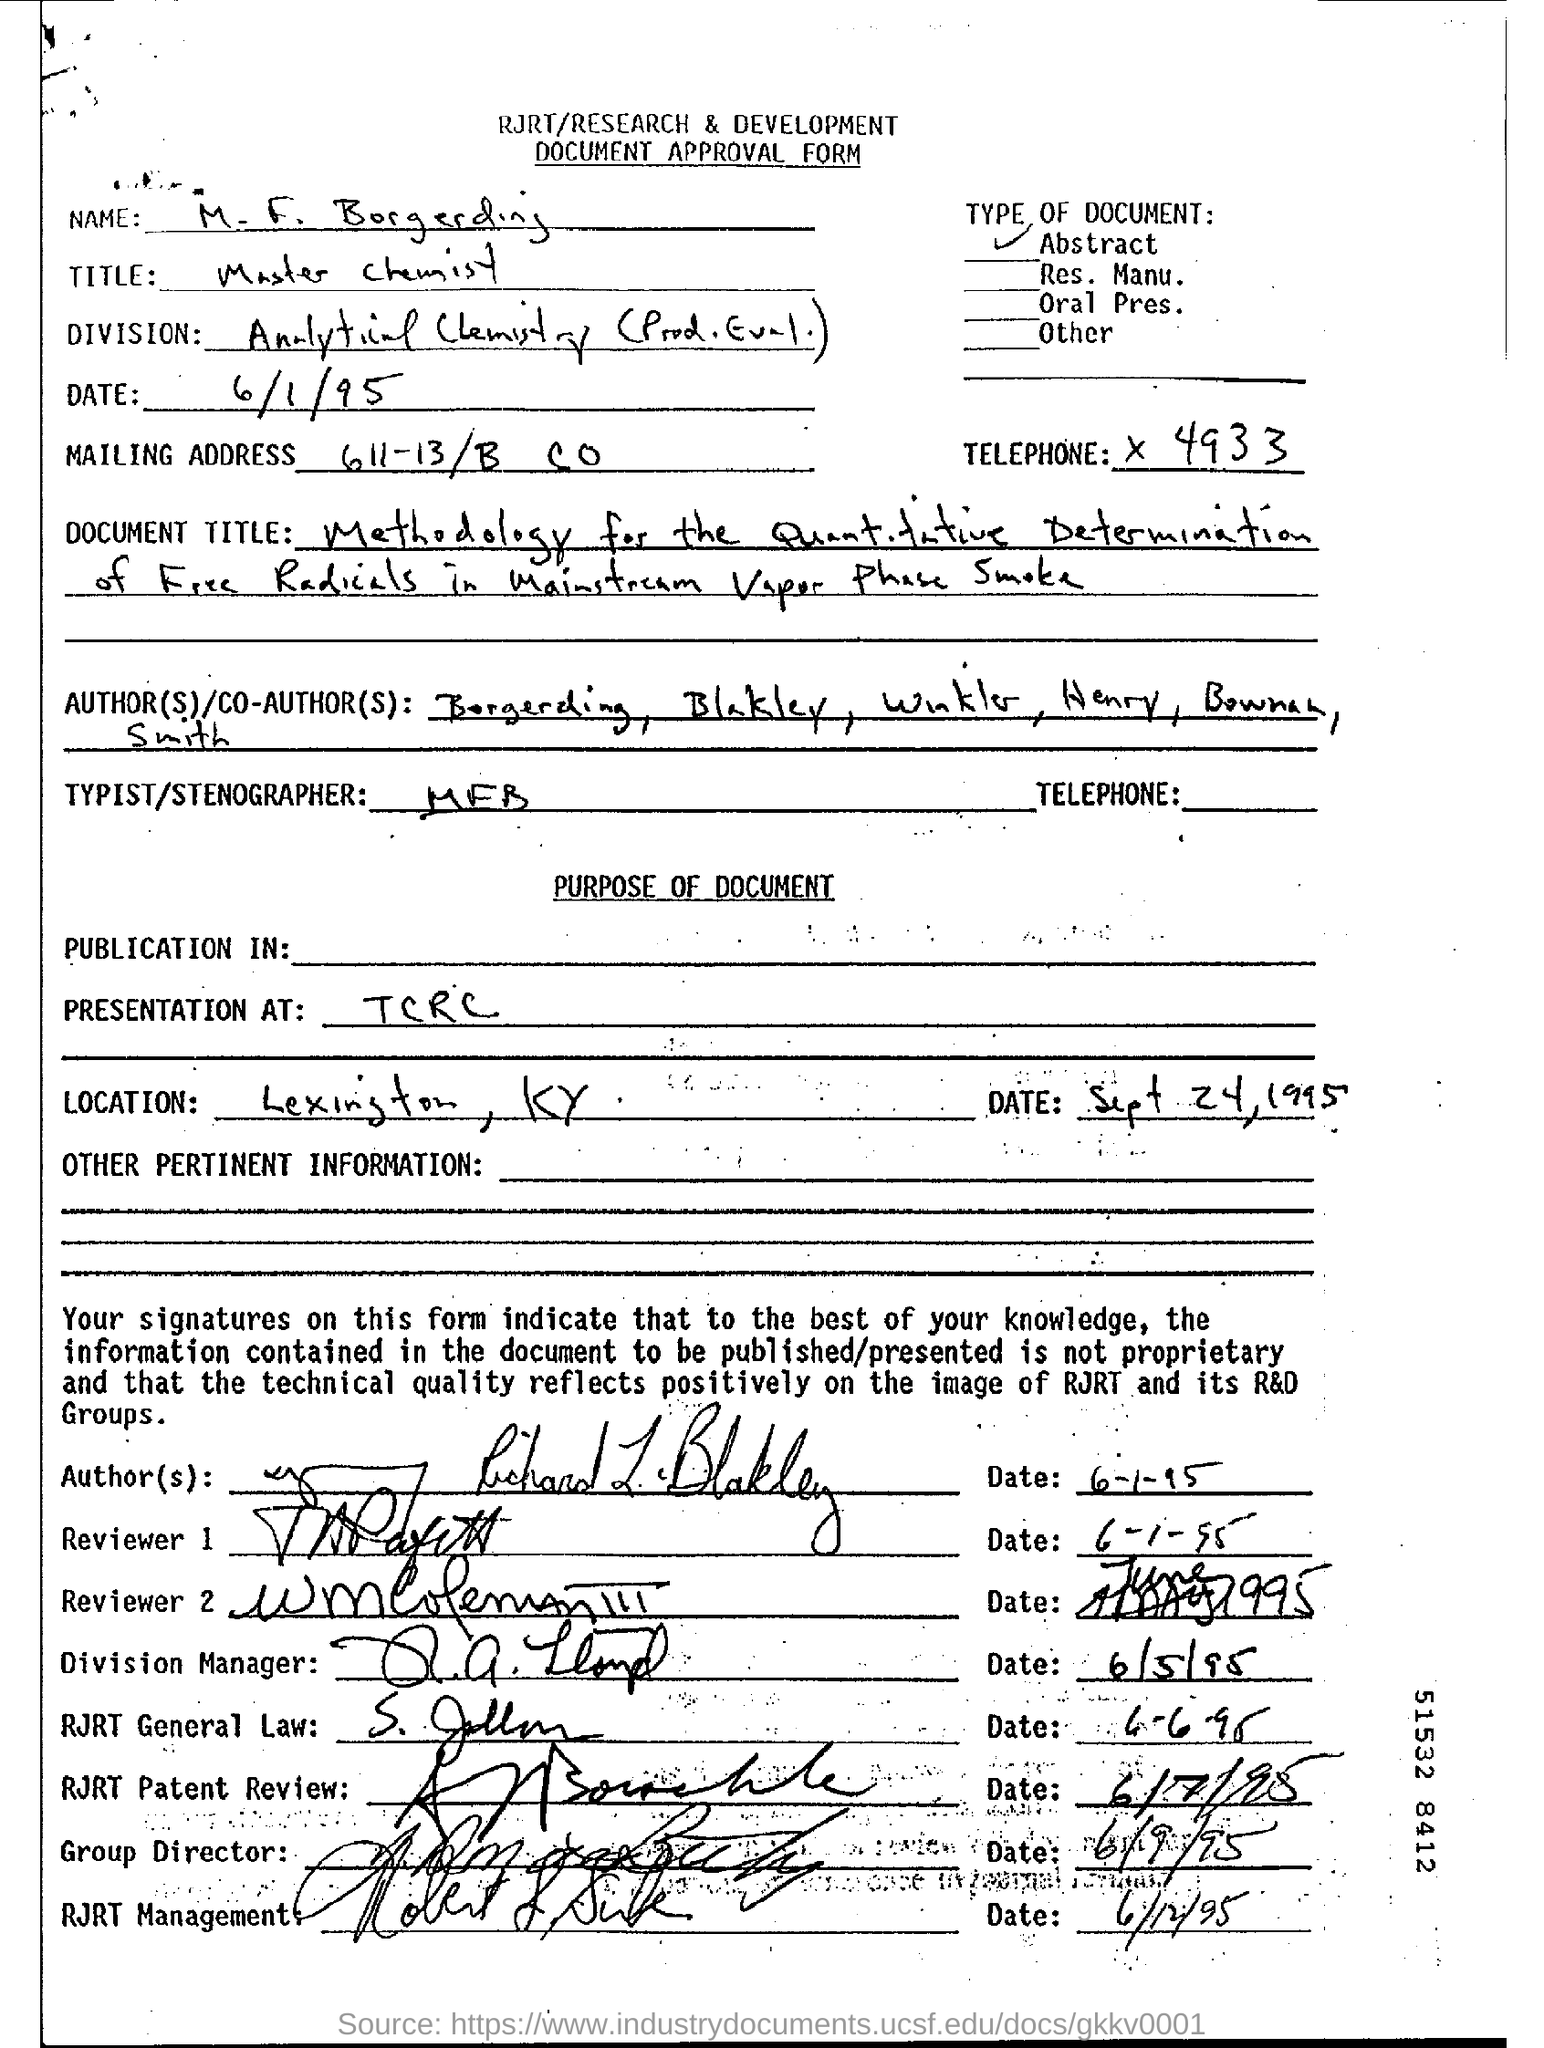Identify some key points in this picture. The telephone number is 4933.. The title of the person mentioned in the form is "Master Chemist. The mailing address is 611-13/B CO.. 